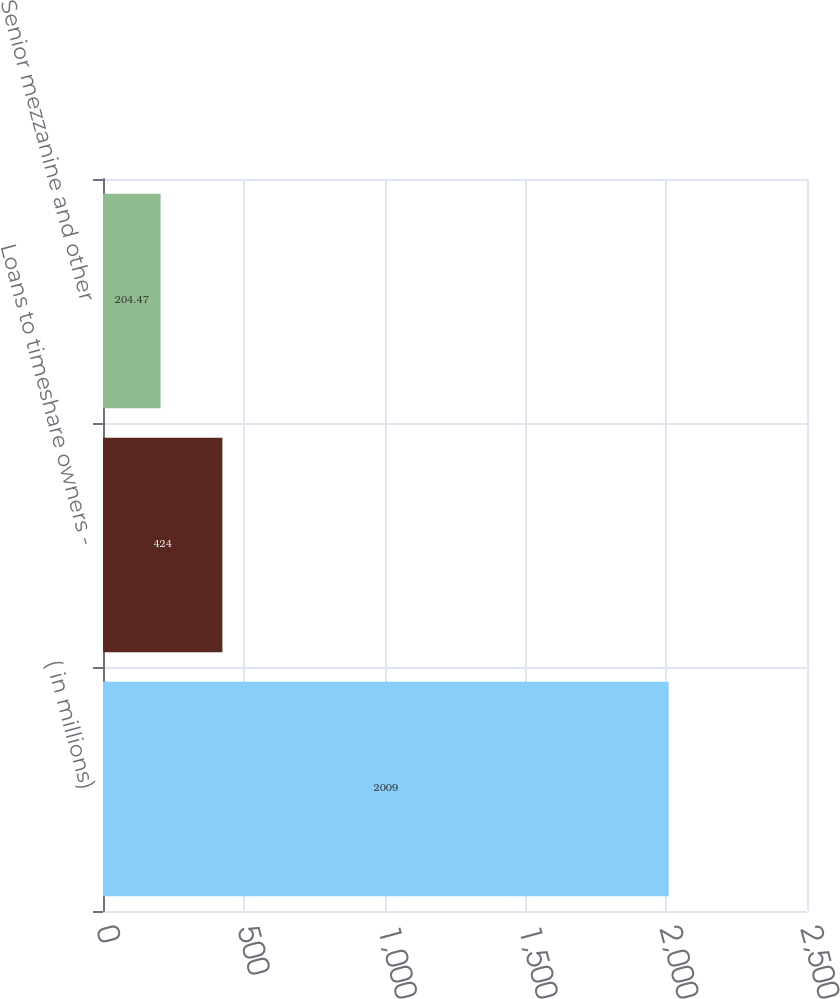Convert chart to OTSL. <chart><loc_0><loc_0><loc_500><loc_500><bar_chart><fcel>( in millions)<fcel>Loans to timeshare owners -<fcel>Senior mezzanine and other<nl><fcel>2009<fcel>424<fcel>204.47<nl></chart> 